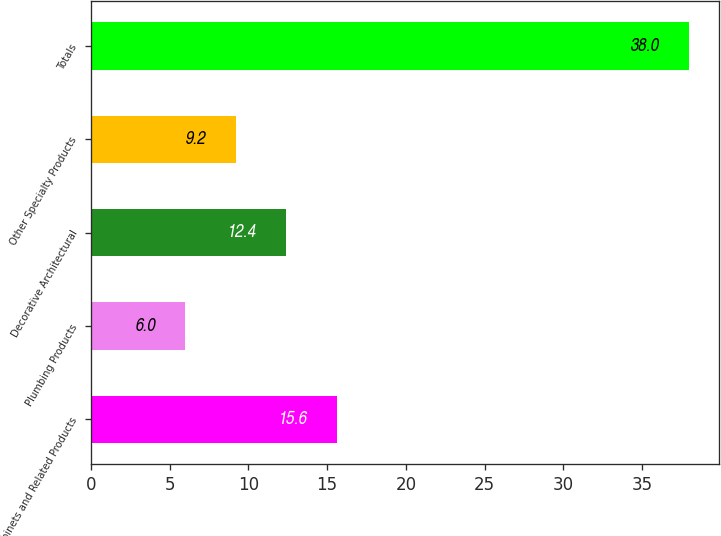Convert chart. <chart><loc_0><loc_0><loc_500><loc_500><bar_chart><fcel>Cabinets and Related Products<fcel>Plumbing Products<fcel>Decorative Architectural<fcel>Other Specialty Products<fcel>Totals<nl><fcel>15.6<fcel>6<fcel>12.4<fcel>9.2<fcel>38<nl></chart> 